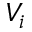Convert formula to latex. <formula><loc_0><loc_0><loc_500><loc_500>V _ { i }</formula> 